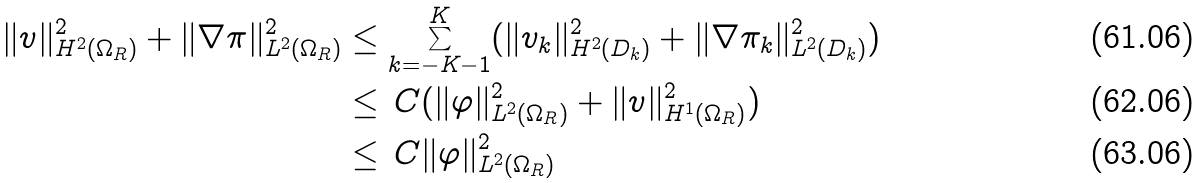<formula> <loc_0><loc_0><loc_500><loc_500>\| v \| _ { H ^ { 2 } ( \Omega _ { R } ) } ^ { 2 } + \| \nabla \pi \| _ { L ^ { 2 } ( \Omega _ { R } ) } ^ { 2 } & \leq \sum _ { k = - K - 1 } ^ { K } ( \| v _ { k } \| _ { H ^ { 2 } ( D _ { k } ) } ^ { 2 } + \| \nabla \pi _ { k } \| _ { L ^ { 2 } ( D _ { k } ) } ^ { 2 } ) \\ & \leq \, C ( \| \varphi \| _ { L ^ { 2 } ( \Omega _ { R } ) } ^ { 2 } + \| v \| _ { H ^ { 1 } ( \Omega _ { R } ) } ^ { 2 } ) \\ & \leq \, C \| \varphi \| _ { L ^ { 2 } ( \Omega _ { R } ) } ^ { 2 }</formula> 